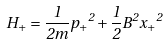<formula> <loc_0><loc_0><loc_500><loc_500>H _ { + } = \frac { 1 } { 2 m } { p _ { + } } ^ { 2 } + \frac { 1 } { 2 } { B } ^ { 2 } { x _ { + } } ^ { 2 }</formula> 